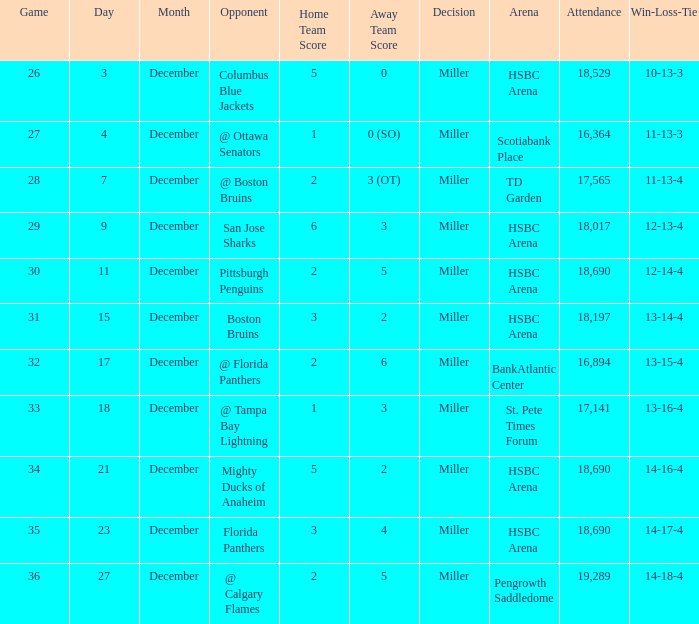Name the number of game 2-6 1.0. Could you parse the entire table as a dict? {'header': ['Game', 'Day', 'Month', 'Opponent', 'Home Team Score', 'Away Team Score', 'Decision', 'Arena', 'Attendance', 'Win-Loss-Tie'], 'rows': [['26', '3', 'December', 'Columbus Blue Jackets', '5', '0', 'Miller', 'HSBC Arena', '18,529', '10-13-3'], ['27', '4', 'December', '@ Ottawa Senators', '1', '0 (SO)', 'Miller', 'Scotiabank Place', '16,364', '11-13-3'], ['28', '7', 'December', '@ Boston Bruins', '2', '3 (OT)', 'Miller', 'TD Garden', '17,565', '11-13-4'], ['29', '9', 'December', 'San Jose Sharks', '6', '3', 'Miller', 'HSBC Arena', '18,017', '12-13-4'], ['30', '11', 'December', 'Pittsburgh Penguins', '2', '5', 'Miller', 'HSBC Arena', '18,690', '12-14-4'], ['31', '15', 'December', 'Boston Bruins', '3', '2', 'Miller', 'HSBC Arena', '18,197', '13-14-4'], ['32', '17', 'December', '@ Florida Panthers', '2', '6', 'Miller', 'BankAtlantic Center', '16,894', '13-15-4'], ['33', '18', 'December', '@ Tampa Bay Lightning', '1', '3', 'Miller', 'St. Pete Times Forum', '17,141', '13-16-4'], ['34', '21', 'December', 'Mighty Ducks of Anaheim', '5', '2', 'Miller', 'HSBC Arena', '18,690', '14-16-4'], ['35', '23', 'December', 'Florida Panthers', '3', '4', 'Miller', 'HSBC Arena', '18,690', '14-17-4'], ['36', '27', 'December', '@ Calgary Flames', '2', '5', 'Miller', 'Pengrowth Saddledome', '19,289', '14-18-4']]} 